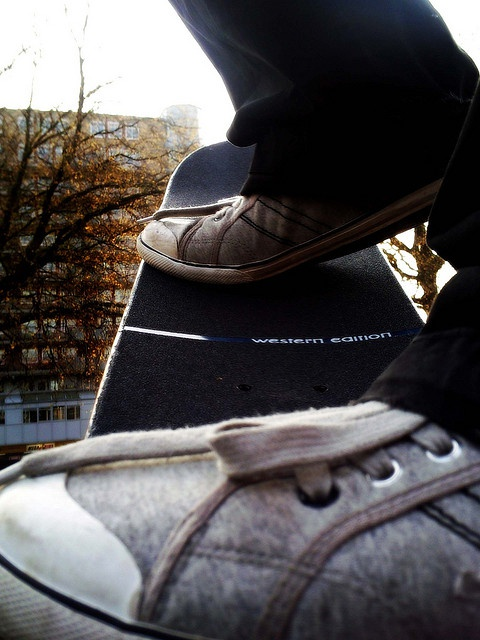Describe the objects in this image and their specific colors. I can see people in white, black, gray, darkgray, and lightgray tones and skateboard in white, black, and gray tones in this image. 